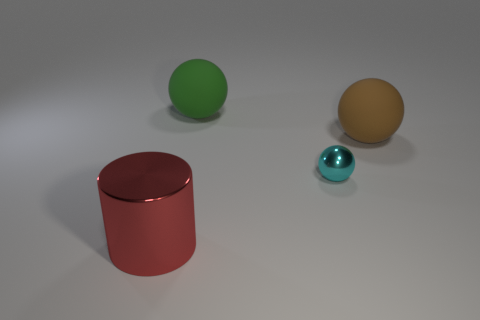What impression does the color choice in this image give you? The use of primary and secondary colors creates a simple yet visually appealing composition. The red, green, and yellow evoke a sense of basic color theory often seen in educational materials, while the cyan adds a touch of contrast and depth to the scene, possibly hinting at a playful or artistic intent behind the color choices. 